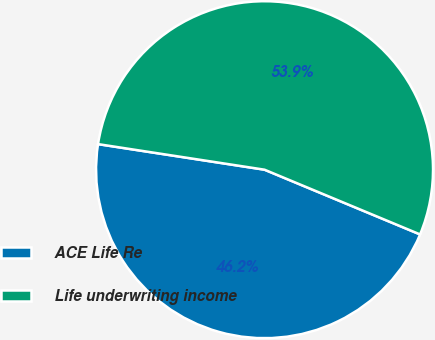Convert chart. <chart><loc_0><loc_0><loc_500><loc_500><pie_chart><fcel>ACE Life Re<fcel>Life underwriting income<nl><fcel>46.15%<fcel>53.85%<nl></chart> 